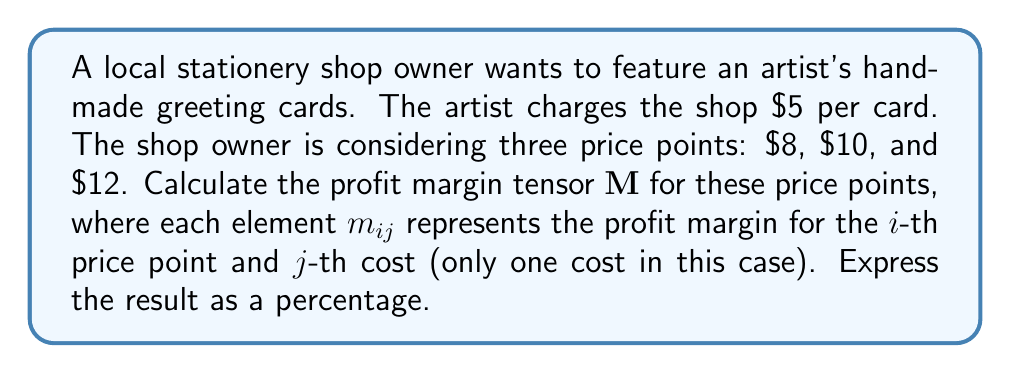Show me your answer to this math problem. To calculate the profit margin tensor, we'll follow these steps:

1) The profit margin formula is:
   $\text{Profit Margin} = \frac{\text{Selling Price} - \text{Cost}}{\text{Selling Price}} \times 100\%$

2) We have three price points and one cost, so our tensor will be a 3x1 matrix.

3) For each price point:

   a) $8 price point:
      m_{11} = \frac{8 - 5}{8} \times 100\% = \frac{3}{8} \times 100\% = 37.5\%$

   b) $10 price point:
      m_{21} = \frac{10 - 5}{10} \times 100\% = \frac{5}{10} \times 100\% = 50\%$

   c) $12 price point:
      m_{31} = \frac{12 - 5}{12} \times 100\% = \frac{7}{12} \times 100\% \approx 58.33\%$

4) We can now construct our profit margin tensor:

   $$\mathbf{M} = \begin{bmatrix}
   37.5 \\
   50.0 \\
   58.33
   \end{bmatrix}$$

This tensor represents the profit margins for each price point as percentages.
Answer: $$\mathbf{M} = \begin{bmatrix}
37.5 \\
50.0 \\
58.33
\end{bmatrix}$$ 